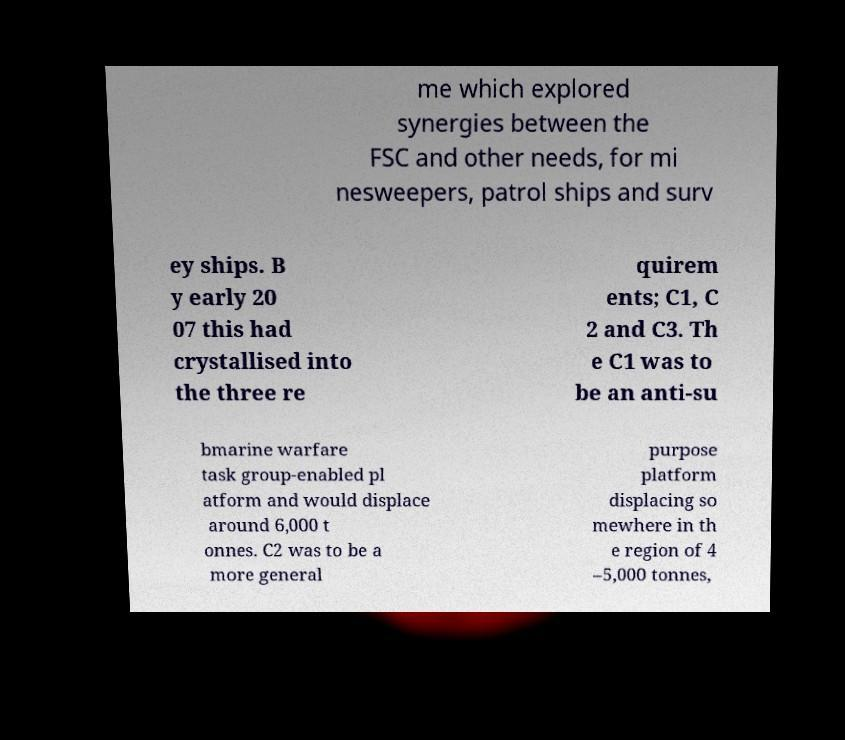Can you read and provide the text displayed in the image?This photo seems to have some interesting text. Can you extract and type it out for me? me which explored synergies between the FSC and other needs, for mi nesweepers, patrol ships and surv ey ships. B y early 20 07 this had crystallised into the three re quirem ents; C1, C 2 and C3. Th e C1 was to be an anti-su bmarine warfare task group-enabled pl atform and would displace around 6,000 t onnes. C2 was to be a more general purpose platform displacing so mewhere in th e region of 4 –5,000 tonnes, 